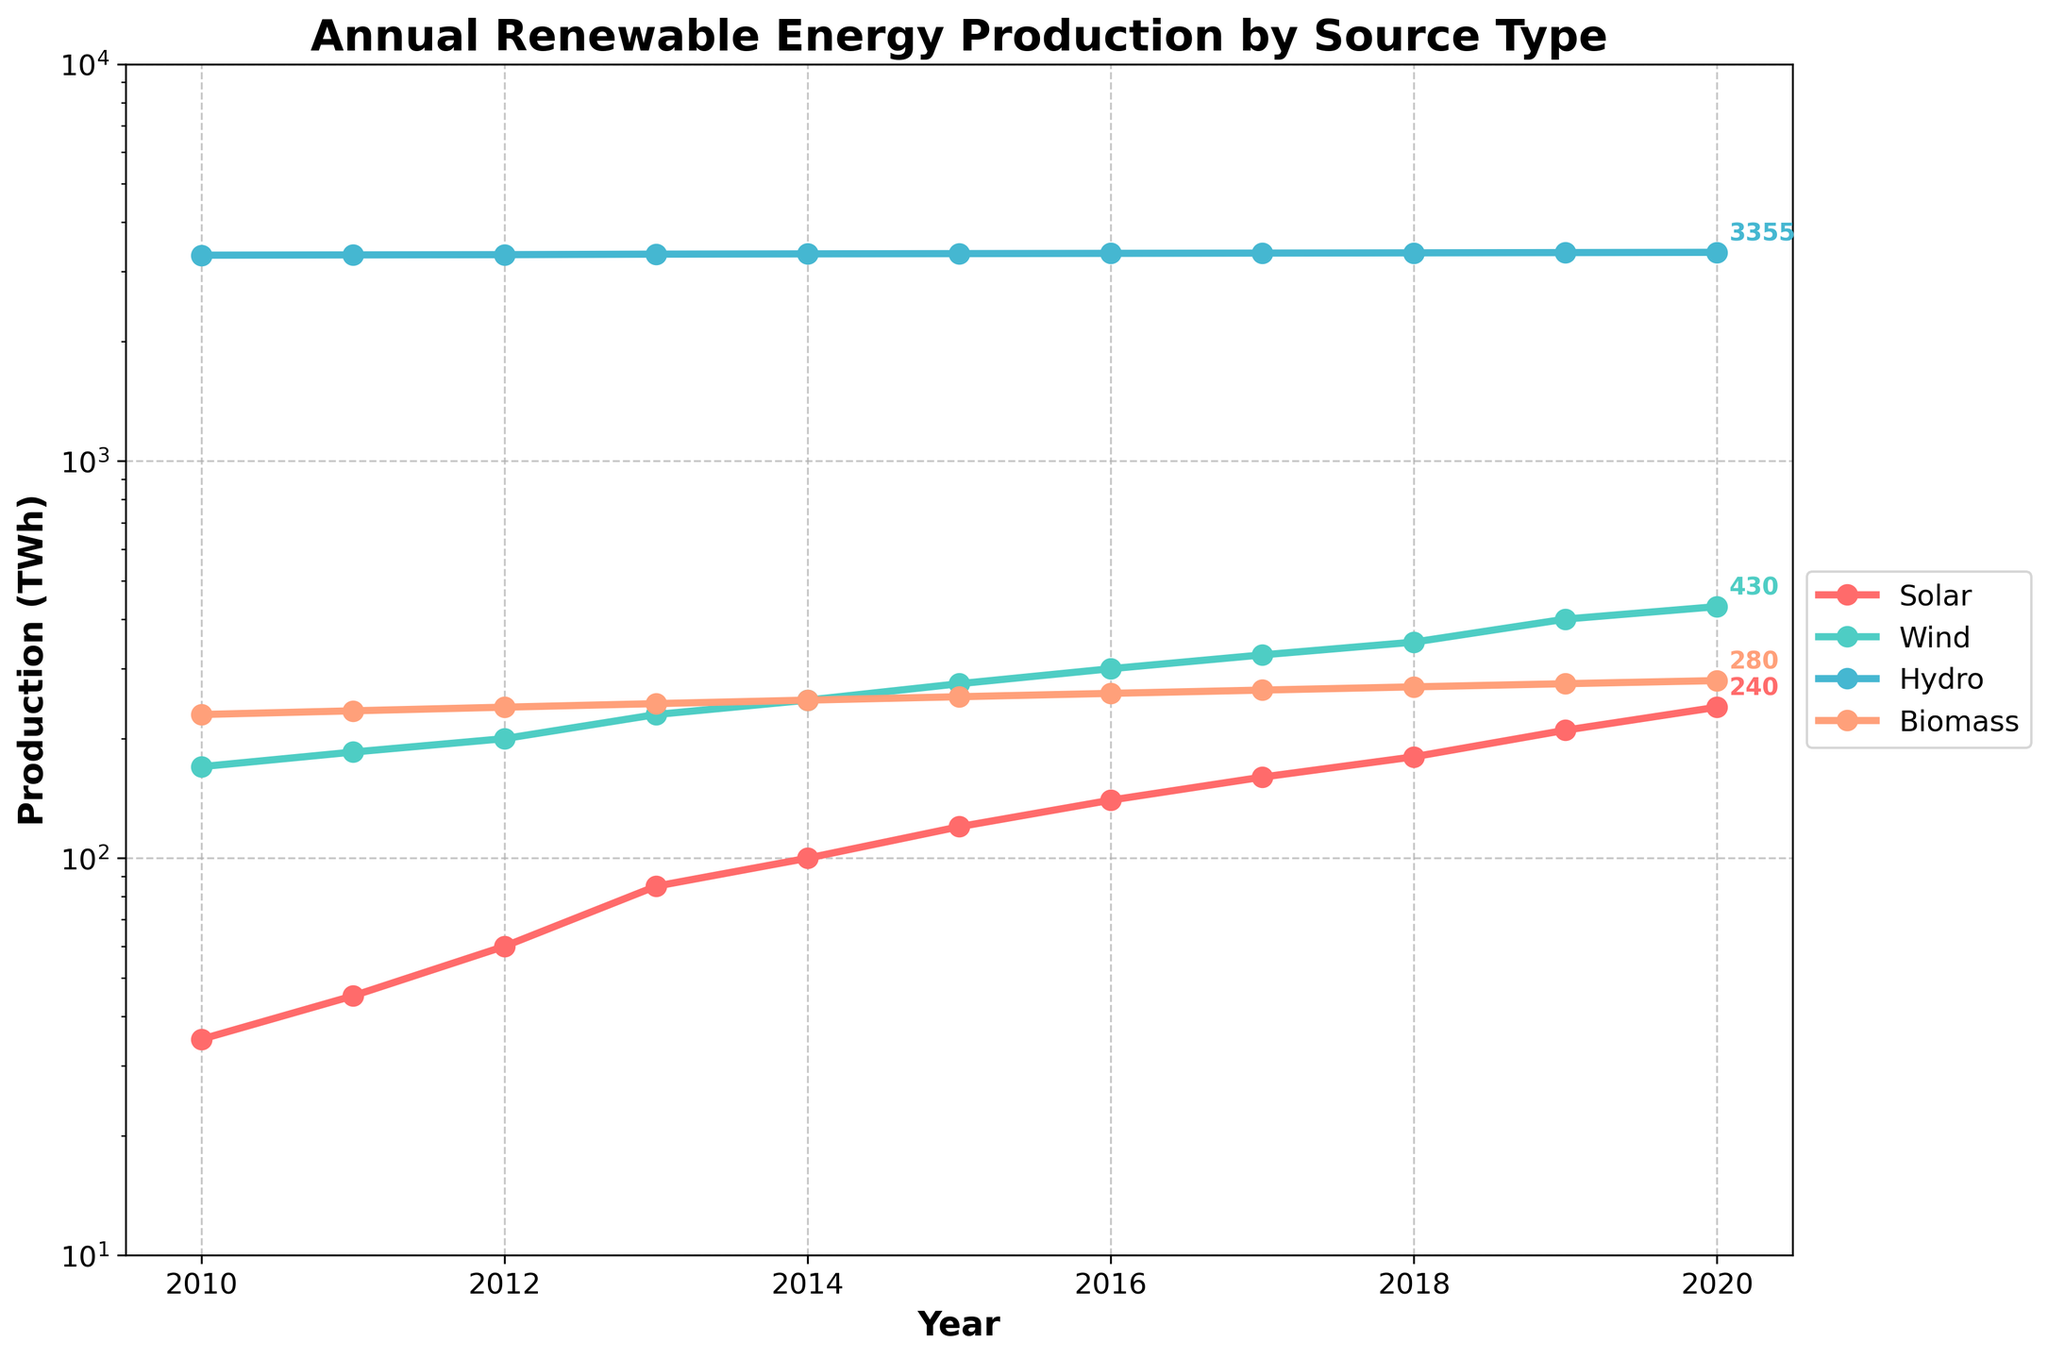What is the title of the plot? The title of the plot is displayed prominently at the top of the figure.
Answer: Annual Renewable Energy Production by Source Type Which source type had the highest production in 2010? By looking at the data points for 2010, Hydro has the highest value among all sources.
Answer: Hydro What is the production increase of Solar energy from 2010 to 2020? First, identify the production values for Solar in 2010 (35 TWh) and 2020 (240 TWh), then subtract the 2010 value from the 2020 value: 240 TWh - 35 TWh = 205 TWh.
Answer: 205 TWh Which source type shows a logarithmic trend in the y-axis? Since the y-axis is set to a logarithmic scale, all source types follow this trend.
Answer: All source types How many source types are displayed in the figure? Count the number of unique source types mentioned in the legend: Solar, Wind, Hydro, Biomass.
Answer: 4 What is the color used for Wind energy in the plot? The color for Wind energy can be identified from the plot's legend and the lines in the figure.
Answer: A shade of greenish-cyan What is the average annual production of Biomass from 2010 to 2020? Locate the Biomass values, add them, then divide by the number of years: (230 + 235 + 240 + 245 + 250 + 255 + 260 + 265 + 270 + 275 + 280)/11 = 256 TWh.
Answer: 256 TWh Which energy source had the smallest increase in production from 2010 to 2020? Determine the increase for each source: Solar (240-35=205 TWh), Wind (430-170=260 TWh), Hydro (3355-3300=55 TWh), Biomass (280-230=50 TWh). Hydro had the smallest increase.
Answer: Hydro By what multiple did Wind energy production increase in 2020 compared to 2010? Compute the ratio of 2020 to 2010 production values: 430 TWh / 170 TWh = 2.53.
Answer: 2.53 Which year had the highest collective renewable energy production? Sum the production for all four sources each year and find the year with the highest total. The highest collective production value corresponds to 2020.
Answer: 2020 